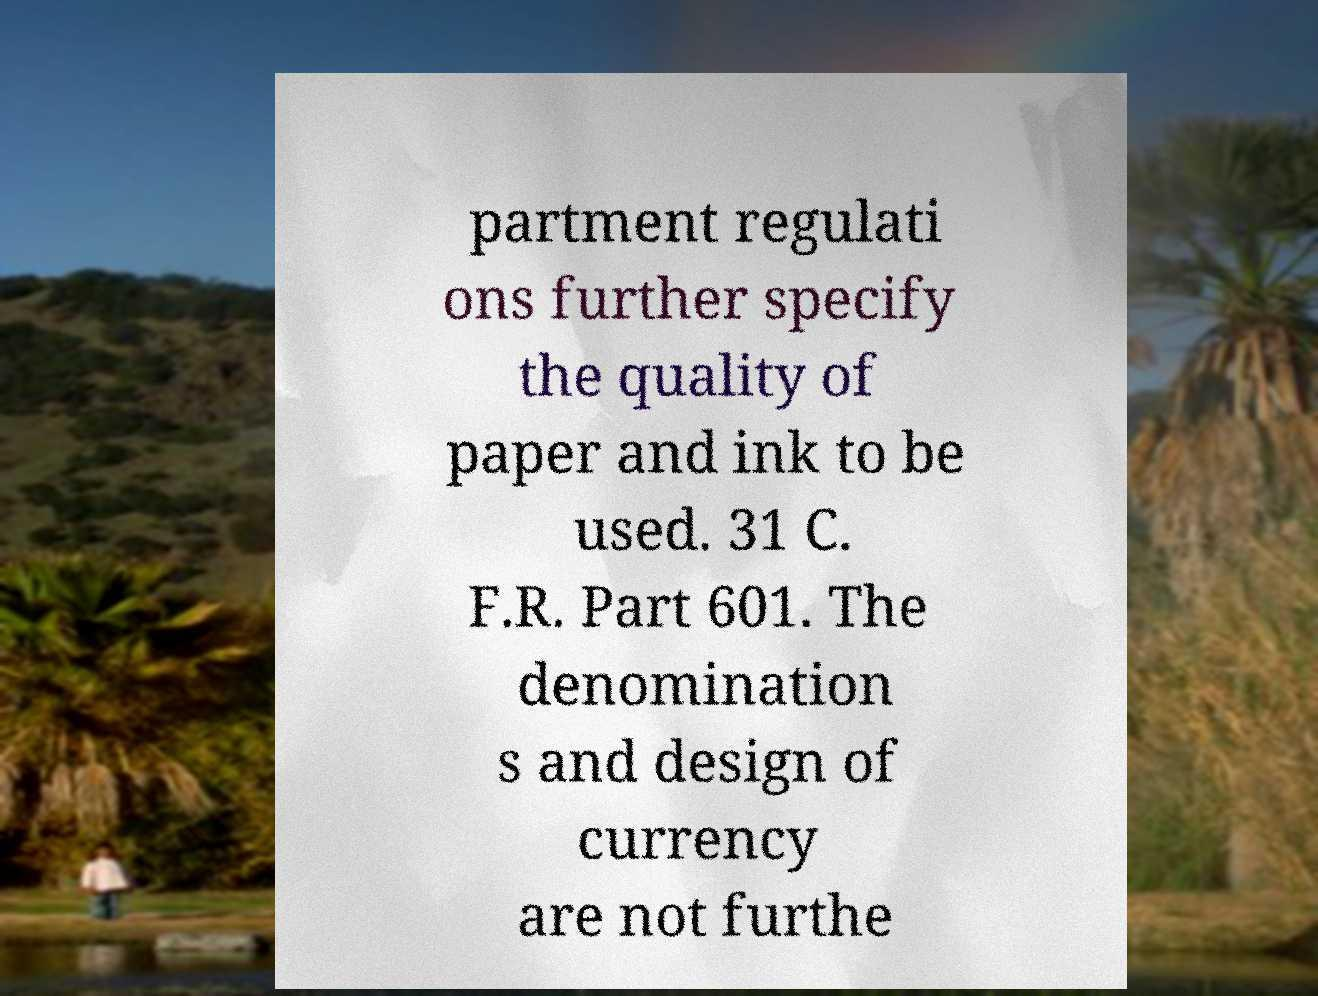There's text embedded in this image that I need extracted. Can you transcribe it verbatim? partment regulati ons further specify the quality of paper and ink to be used. 31 C. F.R. Part 601. The denomination s and design of currency are not furthe 